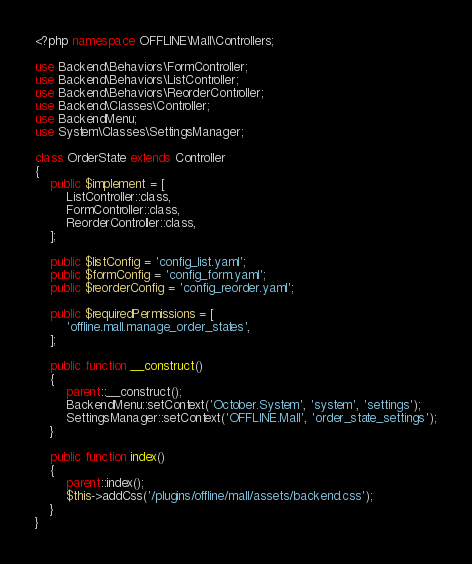<code> <loc_0><loc_0><loc_500><loc_500><_PHP_><?php namespace OFFLINE\Mall\Controllers;

use Backend\Behaviors\FormController;
use Backend\Behaviors\ListController;
use Backend\Behaviors\ReorderController;
use Backend\Classes\Controller;
use BackendMenu;
use System\Classes\SettingsManager;

class OrderState extends Controller
{
    public $implement = [
        ListController::class,
        FormController::class,
        ReorderController::class,
    ];

    public $listConfig = 'config_list.yaml';
    public $formConfig = 'config_form.yaml';
    public $reorderConfig = 'config_reorder.yaml';

    public $requiredPermissions = [
        'offline.mall.manage_order_states',
    ];

    public function __construct()
    {
        parent::__construct();
        BackendMenu::setContext('October.System', 'system', 'settings');
        SettingsManager::setContext('OFFLINE.Mall', 'order_state_settings');
    }

    public function index()
    {
        parent::index();
        $this->addCss('/plugins/offline/mall/assets/backend.css');
    }
}
</code> 